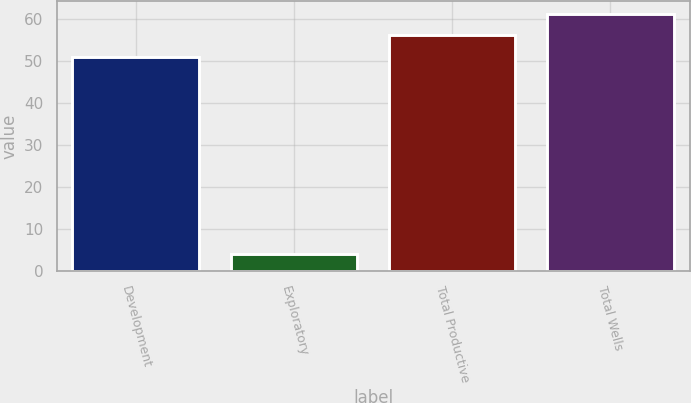Convert chart. <chart><loc_0><loc_0><loc_500><loc_500><bar_chart><fcel>Development<fcel>Exploratory<fcel>Total Productive<fcel>Total Wells<nl><fcel>51<fcel>4<fcel>56.1<fcel>61.2<nl></chart> 